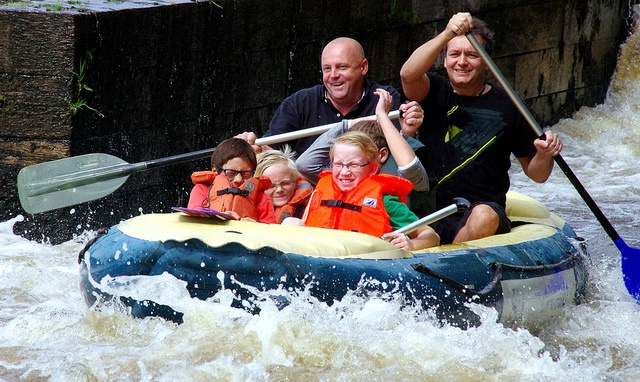Describe the objects in this image and their specific colors. I can see boat in gray, ivory, black, navy, and blue tones, people in gray, black, maroon, tan, and brown tones, people in gray, red, lightgray, and lightpink tones, people in gray, black, brown, lightpink, and maroon tones, and people in gray, maroon, brown, and salmon tones in this image. 